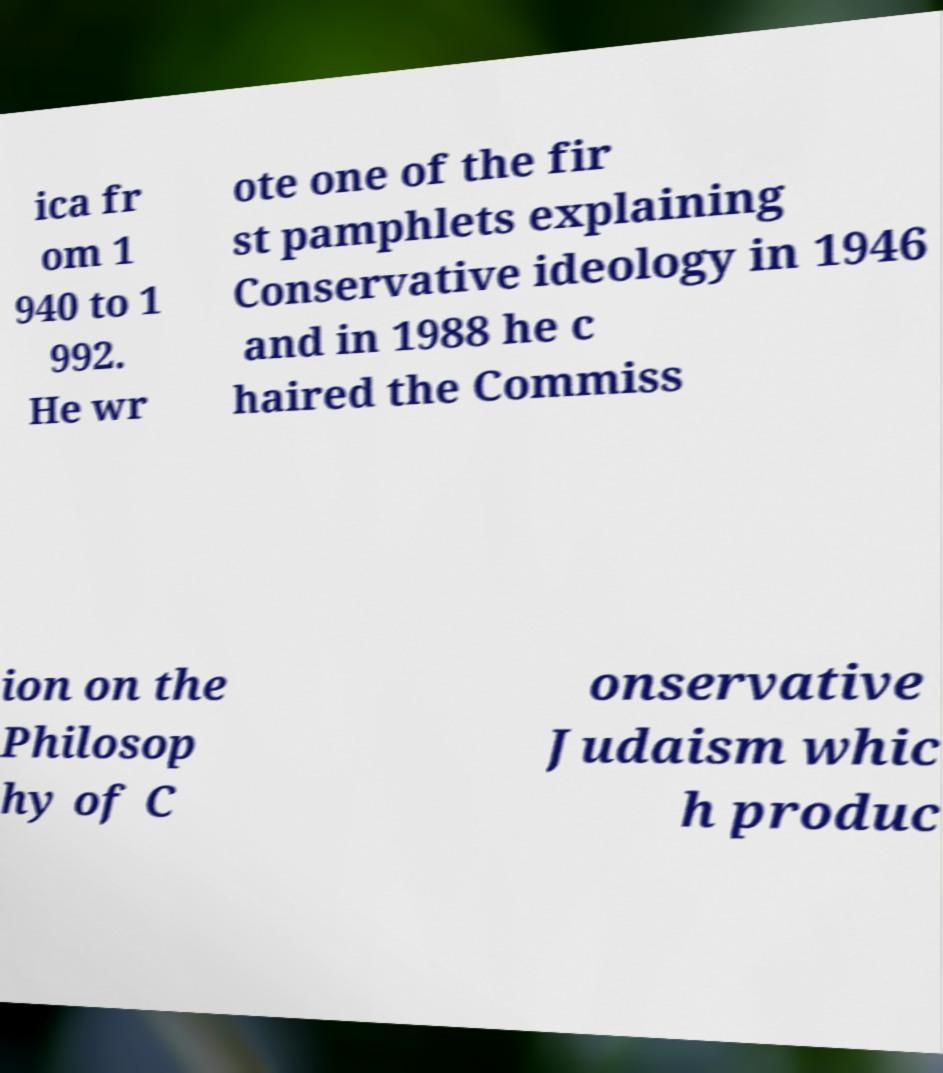Can you read and provide the text displayed in the image?This photo seems to have some interesting text. Can you extract and type it out for me? ica fr om 1 940 to 1 992. He wr ote one of the fir st pamphlets explaining Conservative ideology in 1946 and in 1988 he c haired the Commiss ion on the Philosop hy of C onservative Judaism whic h produc 